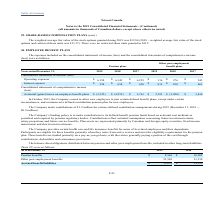According to Loral Space Communications's financial document, When did the company crease to allow new employees to join certain defined benefit plans, except under certain circumstances? According to the financial document, October 2013. The relevant text states: "In October 2013, the Company ceased to allow new employees to join certain defined benefit plans, except under cert..." Also, What are the respective contributions made by the company for various defined contribution arrangements in 2018 and 2019 respectively? The document shows two values: $0.9 and $1.2 (in millions). From the document: "The Company made contributions of $1.2 million for various defined contribution arrangements during 2019 (December 31, 2018 — $0.9 million)...." Also, What are the company's respective accrued benefit liabilities as at December 31, 2018 and 2019 respectively? The document shows two values: $32,235 and $32,074. From the document: "Accrued benefit liabilities $ 32,074 $ 32,235 Accrued benefit liabilities $ 32,074 $ 32,235..." Also, can you calculate: What is the company's total accrued benefits as at December 31, 2018 and 2019? Based on the calculation: 32,235 +32,074 , the result is 64309. This is based on the information: "Accrued benefit liabilities $ 32,074 $ 32,235 Accrued benefit liabilities $ 32,074 $ 32,235..." The key data points involved are: 32,074, 32,235. Also, can you calculate: What is the company's percentage change in other post-employment benefits between 2018 and 2019? To answer this question, I need to perform calculations using the financial data. The calculation is: (23,508 - 21,330)/21,330 , which equals 10.21 (percentage). This is based on the information: "Other post-employment benefits 23,508 21,330 Other post-employment benefits 23,508 21,330..." The key data points involved are: 21,330, 23,508. Also, can you calculate: What is the total pension benefits accrued by the company in 2018 and 2019? Based on the calculation: 8,566 + 10,905 , the result is 19471. This is based on the information: "Pension benefits $ 8,566 $ 10,905 Pension benefits $ 8,566 $ 10,905..." The key data points involved are: 10,905, 8,566. 